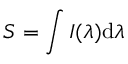Convert formula to latex. <formula><loc_0><loc_0><loc_500><loc_500>S = \int I ( \lambda ) d \lambda</formula> 